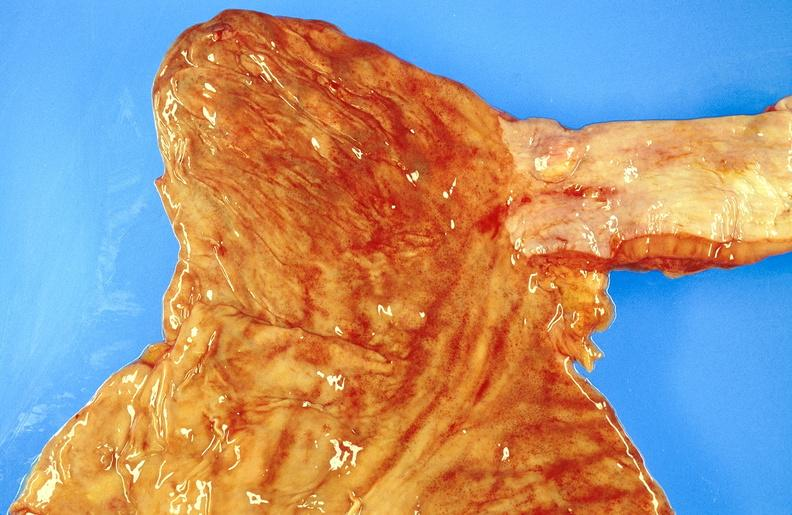what does this image show?
Answer the question using a single word or phrase. Esophagus 